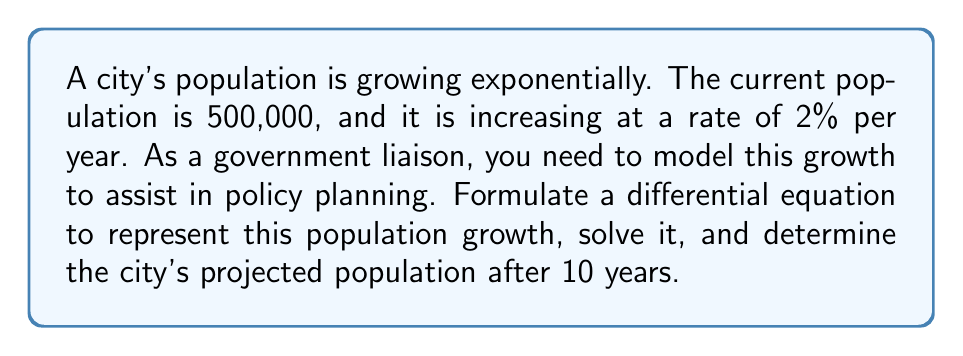Help me with this question. Let's approach this step-by-step:

1) Let $P(t)$ represent the population at time $t$ (in years), with $t=0$ being the current time.

2) The rate of change of the population is proportional to the current population:

   $$\frac{dP}{dt} = kP$$

   where $k$ is the growth rate constant.

3) We're given that the growth rate is 2% per year, so $k = 0.02$.

4) Our differential equation is now:

   $$\frac{dP}{dt} = 0.02P$$

5) This is a separable differential equation. Let's solve it:

   $$\int \frac{dP}{P} = \int 0.02 dt$$

   $$\ln|P| = 0.02t + C$$

   $$P = e^{0.02t + C} = e^C \cdot e^{0.02t}$$

6) Let $A = e^C$. Then our general solution is:

   $$P(t) = Ae^{0.02t}$$

7) We can find $A$ using the initial condition: $P(0) = 500,000$

   $$500,000 = Ae^{0.02 \cdot 0} = A$$

8) Our particular solution is:

   $$P(t) = 500,000e^{0.02t}$$

9) To find the population after 10 years, we calculate $P(10)$:

   $$P(10) = 500,000e^{0.02 \cdot 10} = 500,000e^{0.2} \approx 610,540$$
Answer: The projected population after 10 years is approximately 610,540 people. 